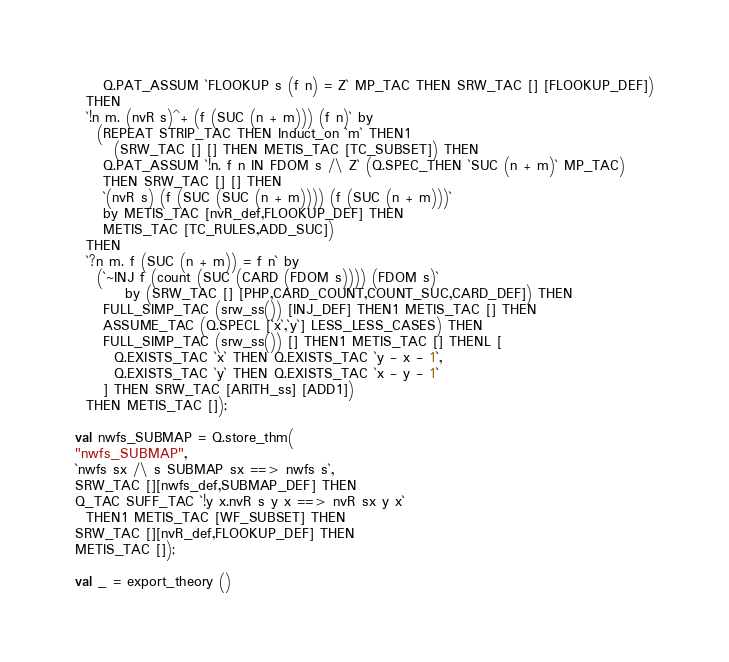<code> <loc_0><loc_0><loc_500><loc_500><_SML_>     Q.PAT_ASSUM `FLOOKUP s (f n) = Z` MP_TAC THEN SRW_TAC [] [FLOOKUP_DEF])
  THEN
  `!n m. (nvR s)^+ (f (SUC (n + m))) (f n)` by
    (REPEAT STRIP_TAC THEN Induct_on `m` THEN1
       (SRW_TAC [] [] THEN METIS_TAC [TC_SUBSET]) THEN
     Q.PAT_ASSUM `!n. f n IN FDOM s /\ Z` (Q.SPEC_THEN `SUC (n + m)` MP_TAC)
     THEN SRW_TAC [] [] THEN
     `(nvR s) (f (SUC (SUC (n + m)))) (f (SUC (n + m)))`
     by METIS_TAC [nvR_def,FLOOKUP_DEF] THEN
     METIS_TAC [TC_RULES,ADD_SUC])
  THEN
  `?n m. f (SUC (n + m)) = f n` by
    (`~INJ f (count (SUC (CARD (FDOM s)))) (FDOM s)`
         by (SRW_TAC [] [PHP,CARD_COUNT,COUNT_SUC,CARD_DEF]) THEN
     FULL_SIMP_TAC (srw_ss()) [INJ_DEF] THEN1 METIS_TAC [] THEN
     ASSUME_TAC (Q.SPECL [`x`,`y`] LESS_LESS_CASES) THEN
     FULL_SIMP_TAC (srw_ss()) [] THEN1 METIS_TAC [] THENL [
       Q.EXISTS_TAC `x` THEN Q.EXISTS_TAC `y - x - 1`,
       Q.EXISTS_TAC `y` THEN Q.EXISTS_TAC `x - y - 1`
     ] THEN SRW_TAC [ARITH_ss] [ADD1])
  THEN METIS_TAC []);

val nwfs_SUBMAP = Q.store_thm(
"nwfs_SUBMAP",
`nwfs sx /\ s SUBMAP sx ==> nwfs s`,
SRW_TAC [][nwfs_def,SUBMAP_DEF] THEN
Q_TAC SUFF_TAC `!y x.nvR s y x ==> nvR sx y x`
  THEN1 METIS_TAC [WF_SUBSET] THEN
SRW_TAC [][nvR_def,FLOOKUP_DEF] THEN
METIS_TAC []);

val _ = export_theory ()
</code> 